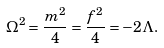Convert formula to latex. <formula><loc_0><loc_0><loc_500><loc_500>\Omega ^ { 2 } = \frac { m ^ { 2 } } 4 = \frac { f ^ { 2 } } 4 = - 2 \Lambda .</formula> 